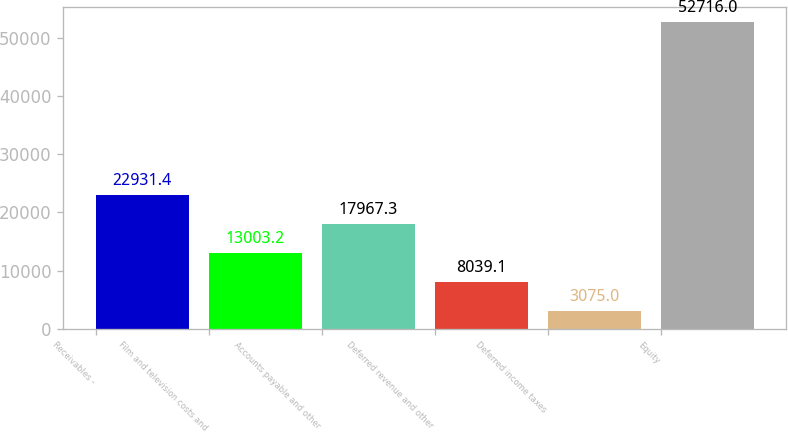<chart> <loc_0><loc_0><loc_500><loc_500><bar_chart><fcel>Receivables -<fcel>Film and television costs and<fcel>Accounts payable and other<fcel>Deferred revenue and other<fcel>Deferred income taxes<fcel>Equity<nl><fcel>22931.4<fcel>13003.2<fcel>17967.3<fcel>8039.1<fcel>3075<fcel>52716<nl></chart> 